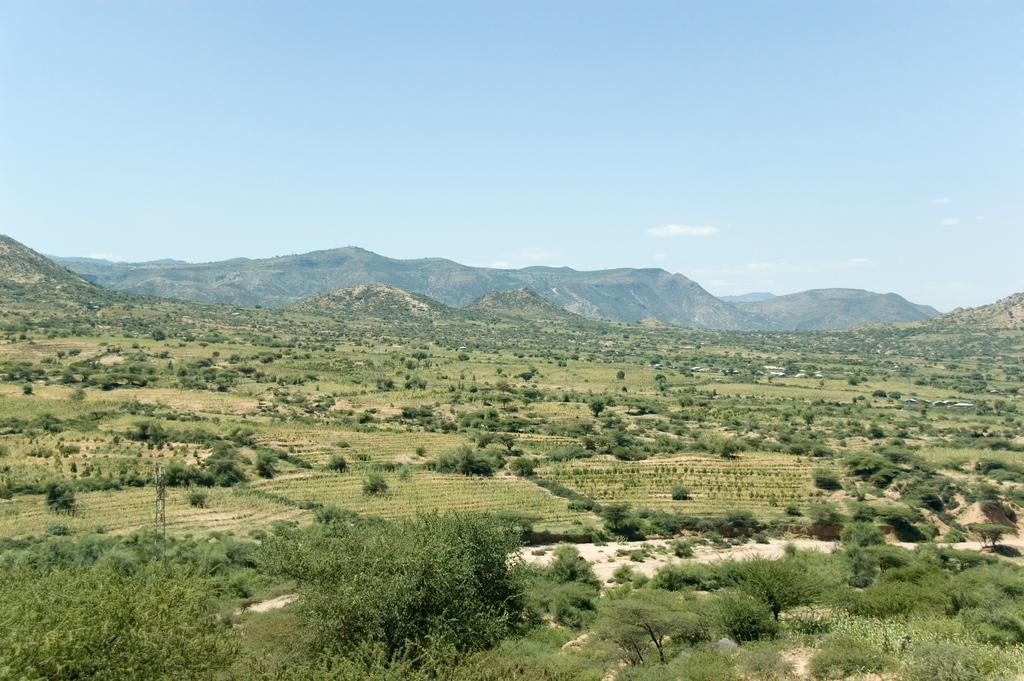What type of vegetation can be seen in the image? There are many trees, plants, and grass visible in the image. What is the terrain like in the image? There are hills visible in the background of the image. What is visible at the top of the image? The sky is visible at the top of the image. What type of vase can be seen on the hill in the image? There is no vase present in the image; it features trees, plants, grass, hills, and the sky. What emotion can be seen on the faces of the trees in the image? Trees do not have faces or emotions, so this cannot be determined from the image. 